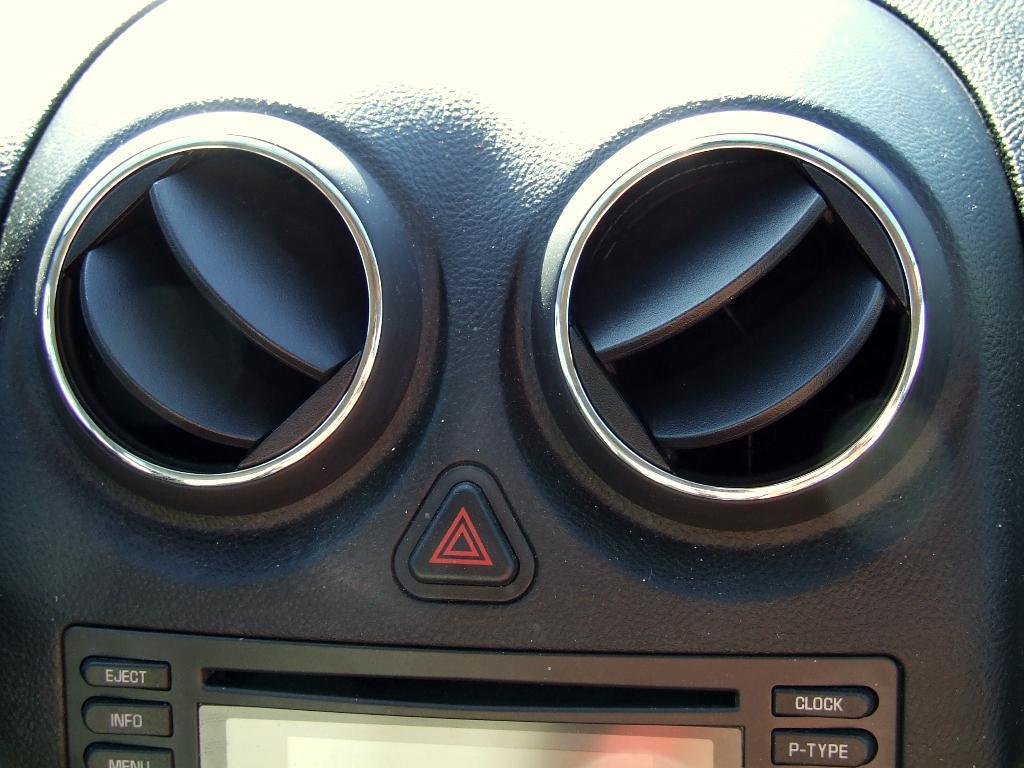Can you describe this image briefly? This image is taken in a car. In this image there are two AC vents and a few buttons. 